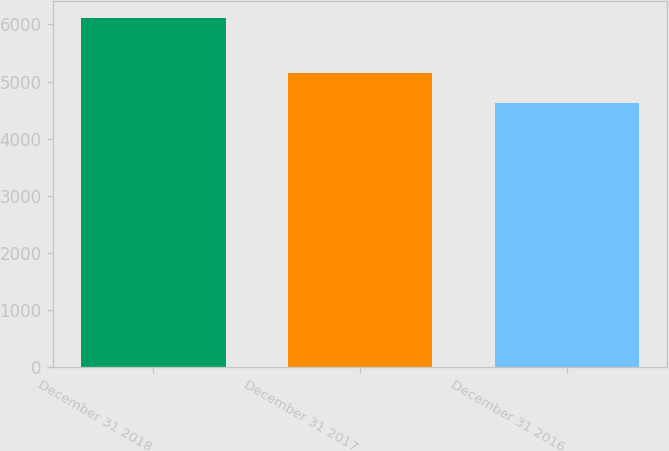Convert chart. <chart><loc_0><loc_0><loc_500><loc_500><bar_chart><fcel>December 31 2018<fcel>December 31 2017<fcel>December 31 2016<nl><fcel>6109<fcel>5141<fcel>4617<nl></chart> 